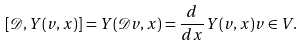<formula> <loc_0><loc_0><loc_500><loc_500>[ \mathcal { D } , Y ( v , x ) ] = Y ( \mathcal { D } v , x ) = \frac { d } { d x } Y ( v , x ) v \in V .</formula> 